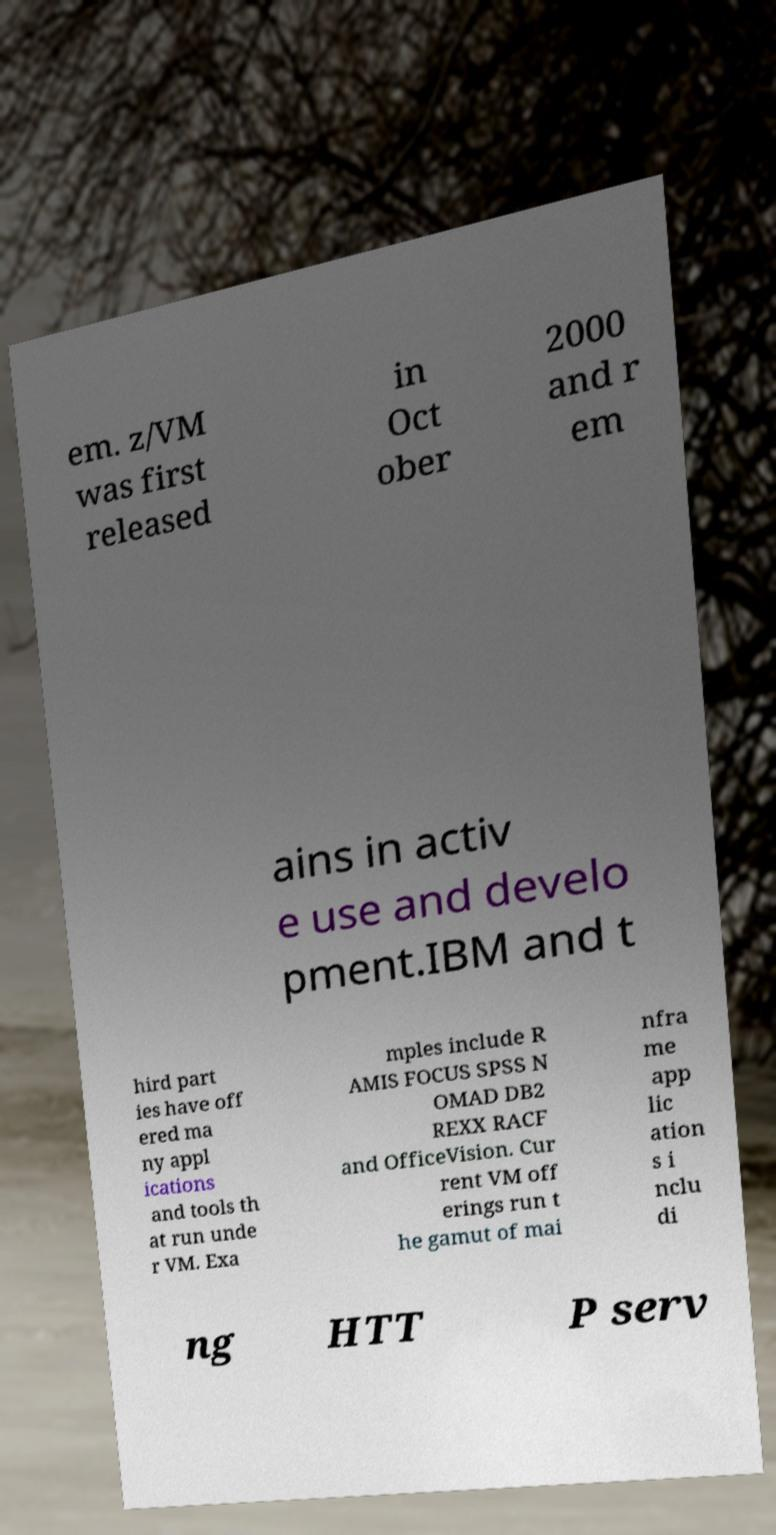I need the written content from this picture converted into text. Can you do that? em. z/VM was first released in Oct ober 2000 and r em ains in activ e use and develo pment.IBM and t hird part ies have off ered ma ny appl ications and tools th at run unde r VM. Exa mples include R AMIS FOCUS SPSS N OMAD DB2 REXX RACF and OfficeVision. Cur rent VM off erings run t he gamut of mai nfra me app lic ation s i nclu di ng HTT P serv 